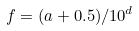Convert formula to latex. <formula><loc_0><loc_0><loc_500><loc_500>f = ( a + 0 . 5 ) / 1 0 ^ { d }</formula> 